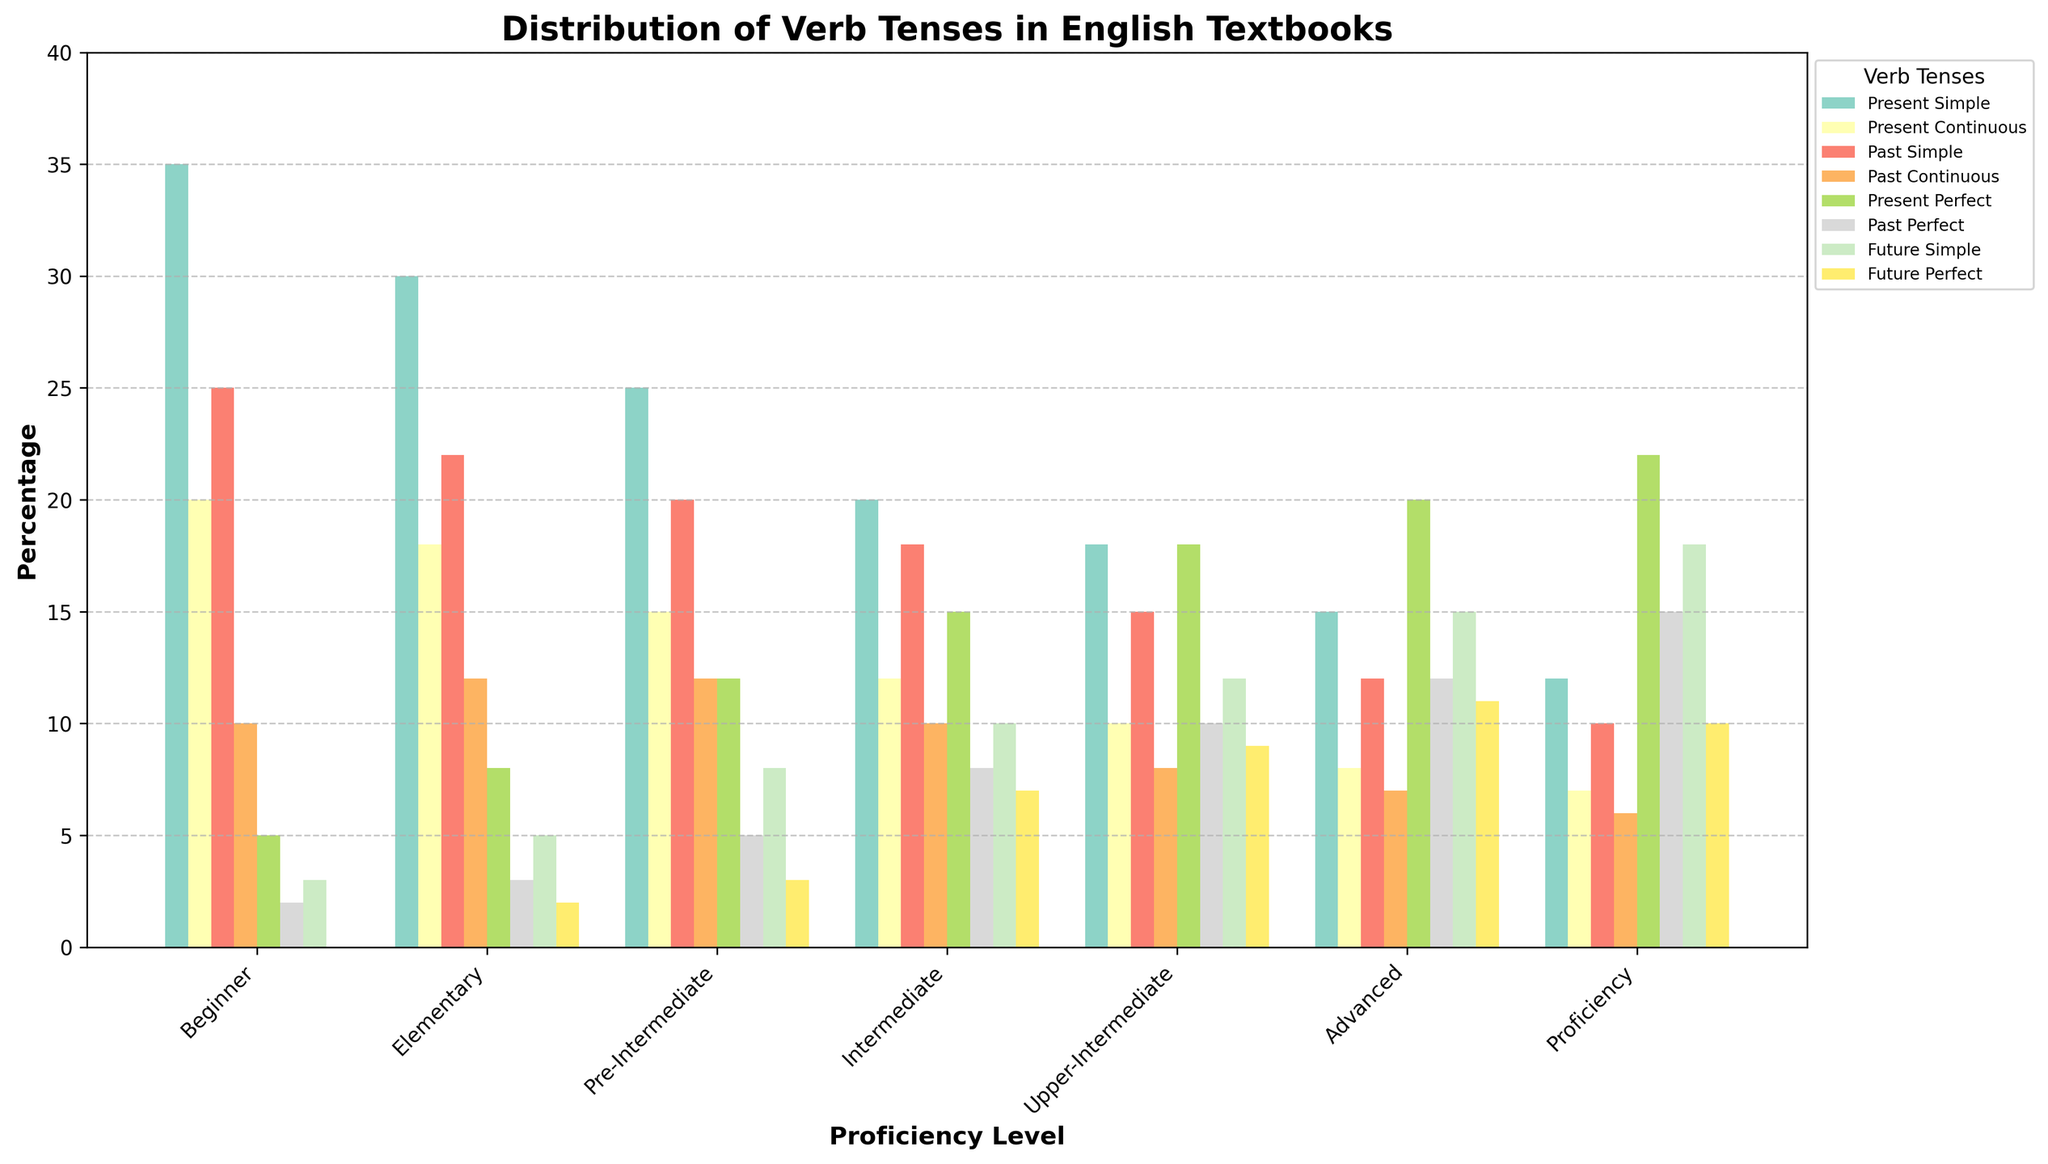What's the percentage range of Past Continuous tense across different proficiency levels? To find the range, locate the maximum and minimum percentages of the Past Continuous tense in the figure. At the Beginner level, it's 10%, and at the Proficiency level, it's 6%. The range is 10% - 6% = 4%.
Answer: 4% Which proficiency level has the highest percentage of Present Simple tense? Find the bars representing Present Simple tense across the different proficiency levels. The tallest bar corresponds to the Beginner level with 35%.
Answer: Beginner How does the percentage of Future Perfect tense change from Advanced to Proficiency? Compare the heights of the Future Perfect bars for the Advanced and Proficiency levels. At the Advanced level, the percentage is 11%, and at the Proficiency level, it's 10%, showing a slight decrease of 1%.
Answer: Decreases by 1% What is the total percentage of Future Simple tense across Intermediate and Upper-Intermediate levels? Sum the percentages of Future Simple tense for Intermediate and Upper-Intermediate levels. For Intermediate, it's 10%, and for Upper-Intermediate, it's 12%. The total is 10% + 12% = 22%.
Answer: 22% Which two tenses have equal percentages at the Beginner level? Look at the bars for the Beginner level to find any tenses with the same height. Both Past Simple and Present Continuous have a percentage of 25%.
Answer: Past Simple and Present Continuous Compare the percentage of Present Perfect tense at Proficiency level with that at Advanced level. Which one is higher, and by how much? Find the Present Perfect bars for Proficiency and Advanced levels. Proficiency has 22%, and Advanced has 20%. Proficiency is higher by 2%.
Answer: Proficiency, 2% Calculate the average percentage of all tenses for the Elementary level. Sum all the tense percentages at the Elementary level: 30% + 18% + 22% + 12% + 8% + 3% + 5% + 2% = 100%. There are 8 tenses, so the average is 100% / 8 = 12.5%.
Answer: 12.5% Which proficiency level shows the largest variety in tense distribution? Identify the range of percentage values of tenses for each level. Compare the differences between the highest and lowest percentages for each level. The Proficiency level ranges from 6% (Past Continuous) to 22% (Present Perfect), giving a range of 16%.
Answer: Proficiency 